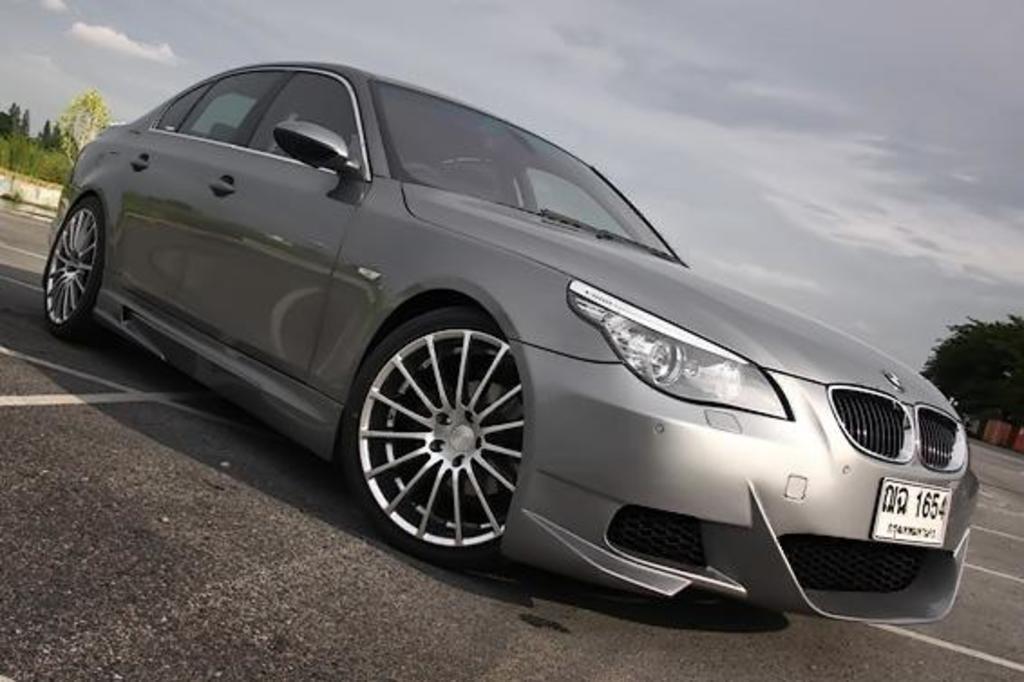Can you describe this image briefly? In this picture there is a silver car parked on the road. Behind we can see some trees. 